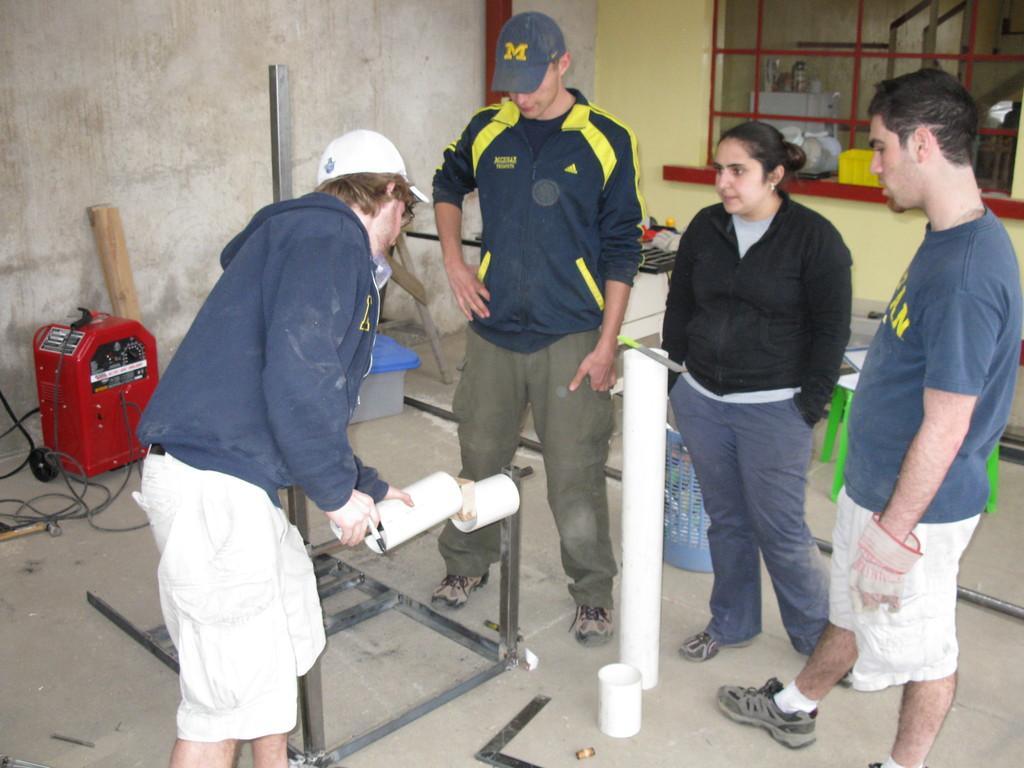Could you give a brief overview of what you see in this image? There is a woman and three men are standing on the floor. On the left a person is holding an object and a pen in his hands,In the background there is a wall,window and an electronic device and poles on the floor and there are some other objects which are not so clear. 